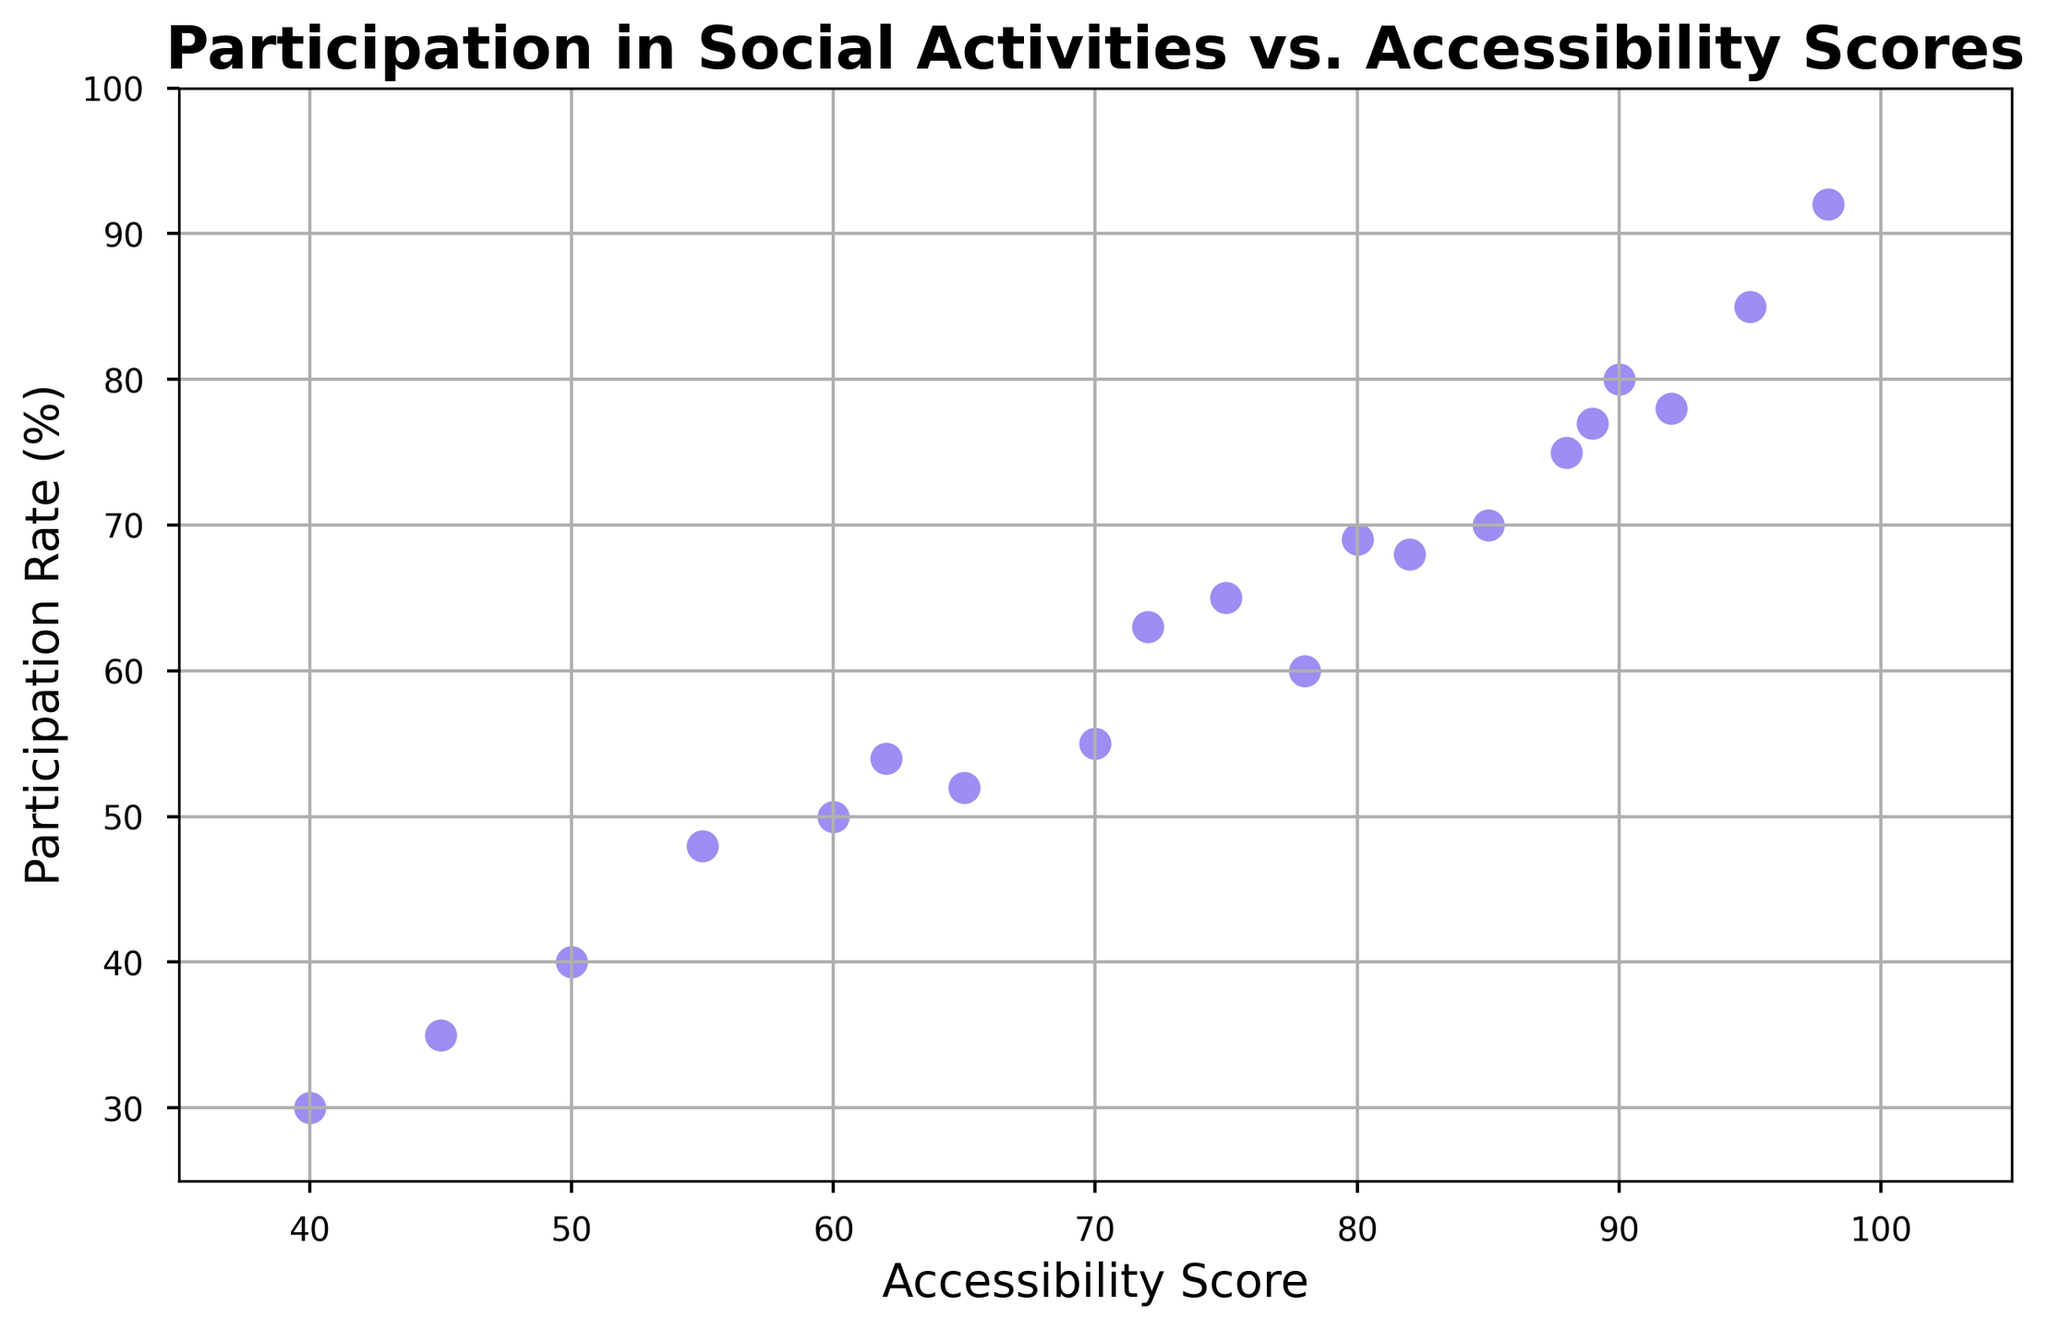What's the average Participation Rate for Accessibility Scores above 80? First, identify the Accessibility Scores above 80, which are 85, 90, 95, 82, 88, and 92. Corresponding Participation Rates are 70, 80, 85, 68, 75, and 78. Sum these Participation Rates: 70 + 80 + 85 + 68 + 75 + 78 = 456. The number of scores is 6, so the average is 456 / 6 = 76
Answer: 76 Which point has the lowest Participation Rate and what is its Accessibility Score? The lowest Participation Rate is 30, which is paired with an Accessibility Score of 40.
Answer: 40 Is there a positive correlation between Participation Rates and Accessibility Scores? The scatter plot shows that as Accessibility Scores increase, Participation Rates also tend to increase, indicating a positive correlation.
Answer: Yes What is the range of Accessibility Scores depicted in the figure? The lowest Accessibility Score is 40, and the highest is 98. Therefore, the range is 98 - 40 = 58.
Answer: 58 Which data point represents the highest Participation Rate, and what is the corresponding Accessibility Score? The highest Participation Rate is 92, which corresponds to an Accessibility Score of 98.
Answer: 98 Compare the Participation Rates for Accessibility Scores 70 and 50. Which is higher? The Participation Rate for an Accessibility Score of 70 is 55, and for a score of 50, it is 40. Therefore, 55 is higher than 40.
Answer: 70 How many data points have an Accessibility Score below 60? Identify the data points with Accessibility Scores below 60: 50, 55, and 40. There are 3 such data points.
Answer: 3 What is the difference in Participation Rate between the highest and lowest Accessibility Scores? The highest Accessibility Score is 98 with a Participation Rate of 92, and the lowest is 40 with a Participation Rate of 30. The difference in Participation Rates is 92 - 30 = 62.
Answer: 62 What is the Participation Rate for an Accessibility Score of 75? The Participation Rate corresponding to an Accessibility Score of 75 is 65.
Answer: 65 For Accessibility Scores between 70 and 80 inclusive, what is the average Participation Rate? Identify data points within the Accessibility Score range: 70 (55), 75 (65), 78 (60), and 80 (69). Corresponding Participation Rates are: 55, 65, 60, and 69. Sum these rates: 55 + 65 + 60 + 69 = 249. The number of scores is 4, so the average is 249 / 4 = 62.25
Answer: 62.25 